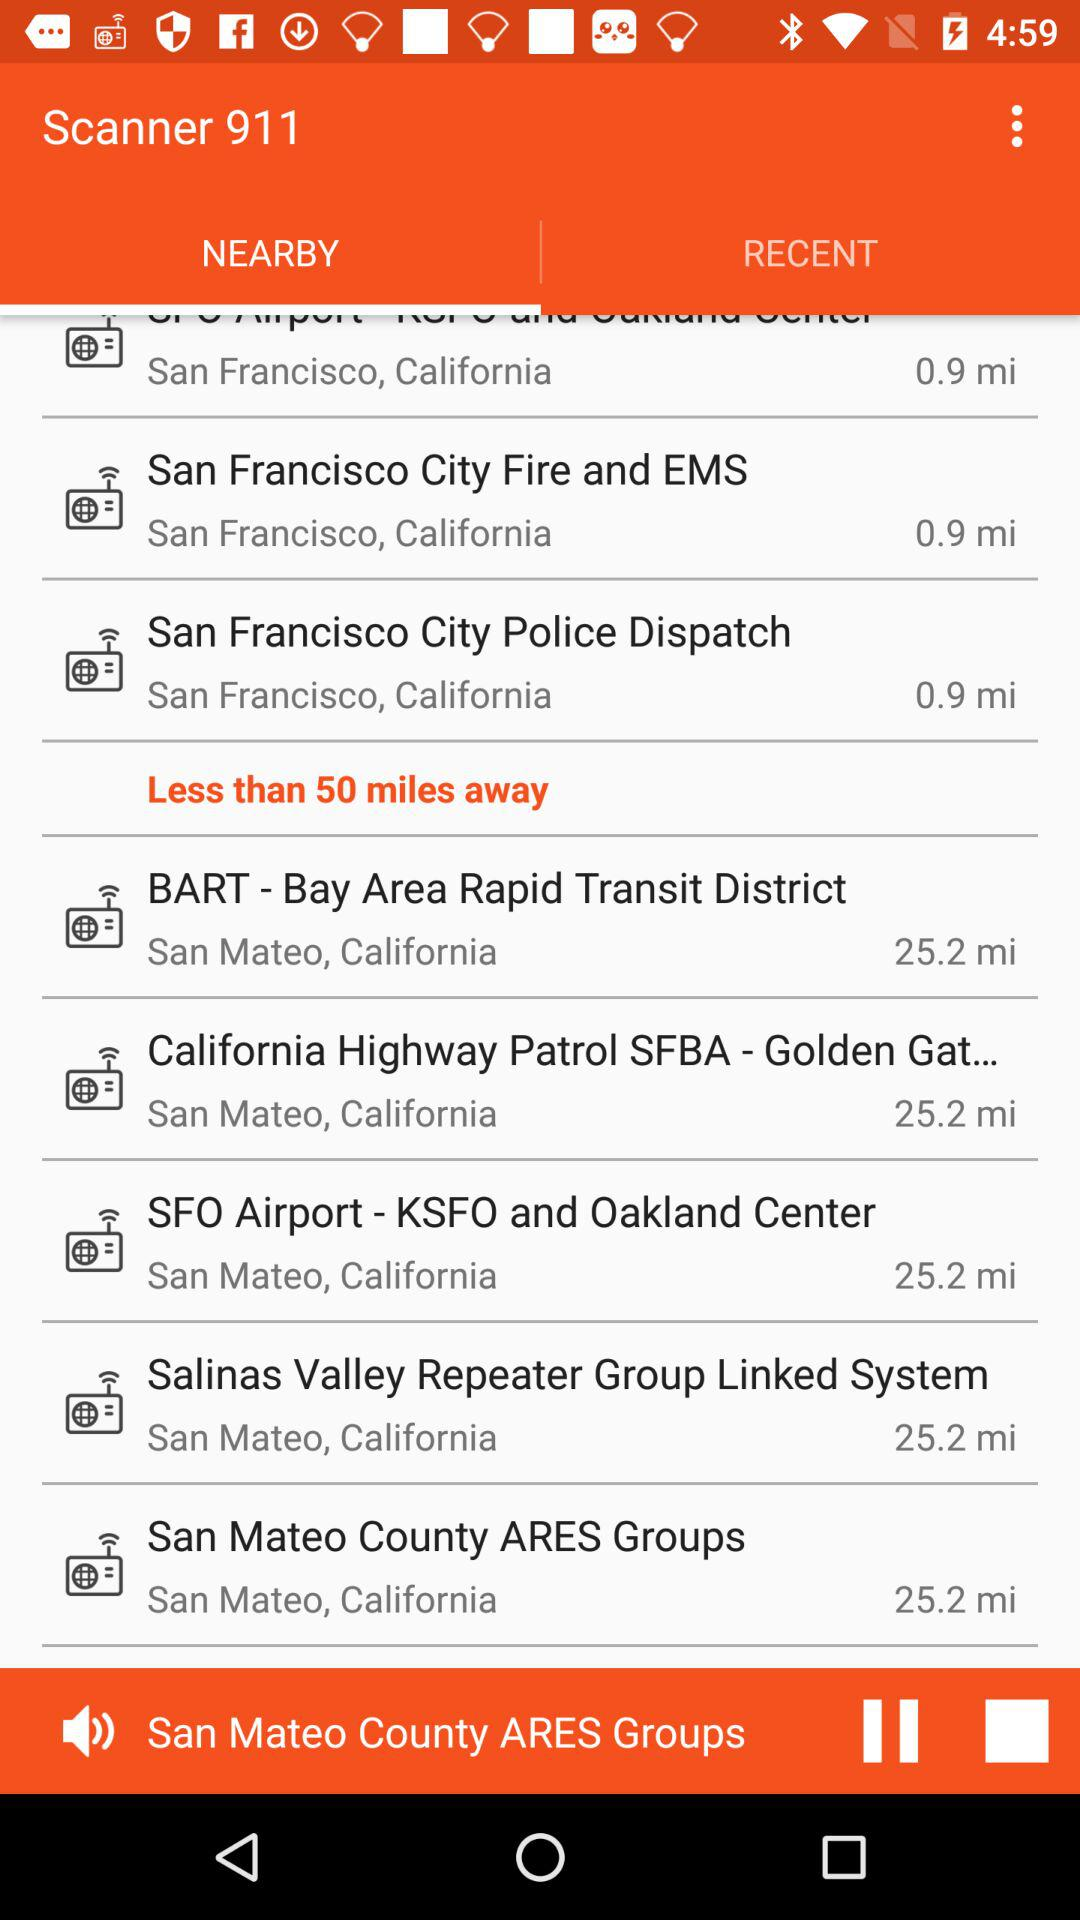Which tab is selected? The selected tab is "Nearby". 